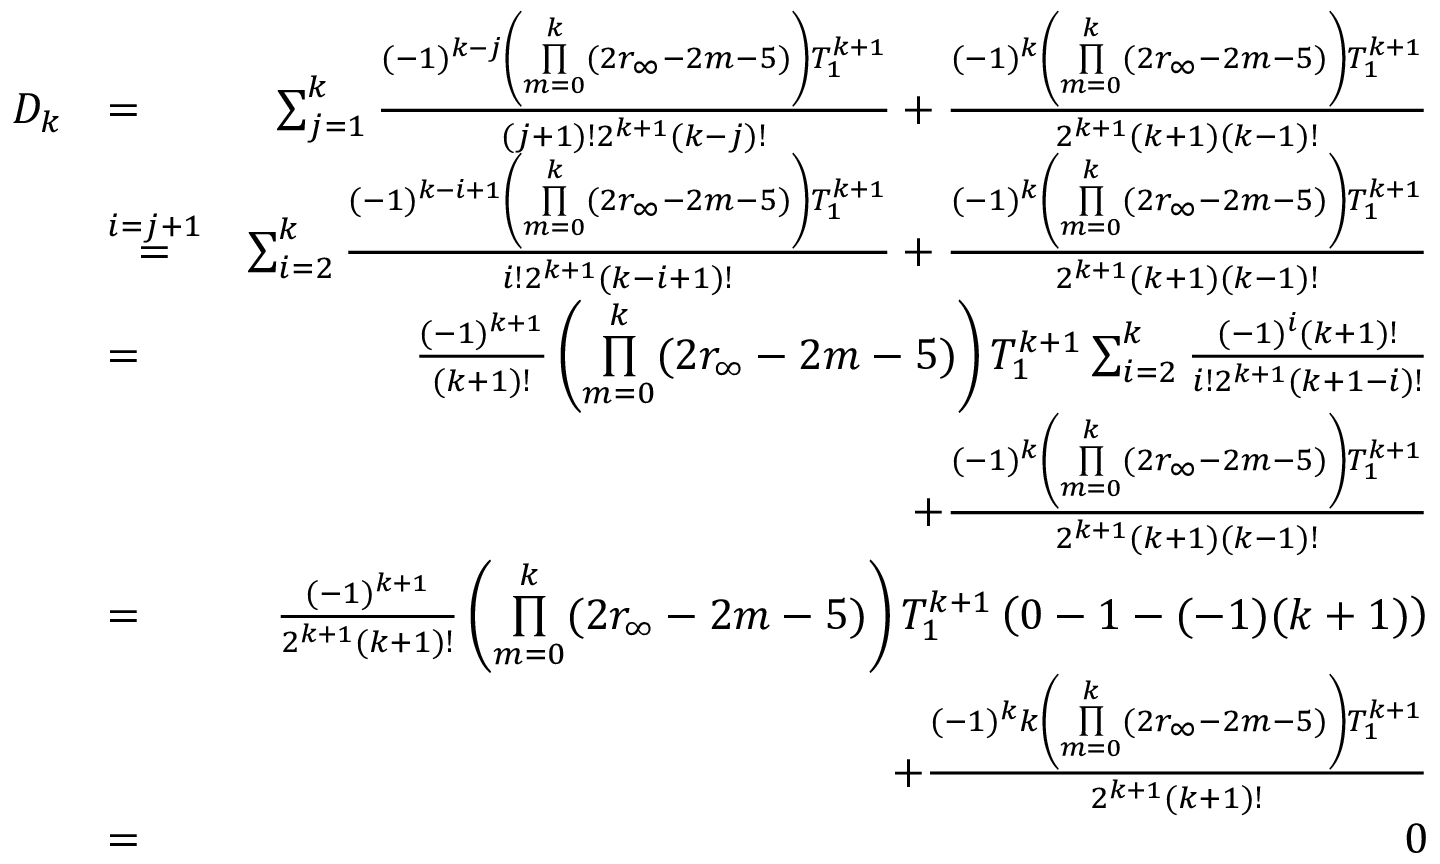Convert formula to latex. <formula><loc_0><loc_0><loc_500><loc_500>\begin{array} { r l r } { D _ { k } } & { = } & { \sum _ { j = 1 } ^ { k } \frac { ( - 1 ) ^ { k - j } \left ( \underset { m = 0 } { \overset { k } { \prod } } ( 2 r _ { \infty } - 2 m - 5 ) \right ) T _ { 1 } ^ { k + 1 } } { ( j + 1 ) ! 2 ^ { k + 1 } ( k - j ) ! } + \frac { ( - 1 ) ^ { k } \left ( \underset { m = 0 } { \overset { k } { \prod } } ( 2 r _ { \infty } - 2 m - 5 ) \right ) T _ { 1 } ^ { k + 1 } } { 2 ^ { k + 1 } ( k + 1 ) ( k - 1 ) ! } } \\ & { \overset { i = j + 1 } { = } } & { \sum _ { i = 2 } ^ { k } \frac { ( - 1 ) ^ { k - i + 1 } \left ( \underset { m = 0 } { \overset { k } { \prod } } ( 2 r _ { \infty } - 2 m - 5 ) \right ) T _ { 1 } ^ { k + 1 } } { i ! 2 ^ { k + 1 } ( k - i + 1 ) ! } + \frac { ( - 1 ) ^ { k } \left ( \underset { m = 0 } { \overset { k } { \prod } } ( 2 r _ { \infty } - 2 m - 5 ) \right ) T _ { 1 } ^ { k + 1 } } { 2 ^ { k + 1 } ( k + 1 ) ( k - 1 ) ! } } \\ & { = } & { \frac { ( - 1 ) ^ { k + 1 } } { ( k + 1 ) ! } \left ( \underset { m = 0 } { \overset { k } { \prod } } ( 2 r _ { \infty } - 2 m - 5 ) \right ) T _ { 1 } ^ { k + 1 } \sum _ { i = 2 } ^ { k } \frac { ( - 1 ) ^ { i } ( k + 1 ) ! } { i ! 2 ^ { k + 1 } ( k + 1 - i ) ! } } \\ & { + \frac { ( - 1 ) ^ { k } \left ( \underset { m = 0 } { \overset { k } { \prod } } ( 2 r _ { \infty } - 2 m - 5 ) \right ) T _ { 1 } ^ { k + 1 } } { 2 ^ { k + 1 } ( k + 1 ) ( k - 1 ) ! } } \\ & { = } & { \frac { ( - 1 ) ^ { k + 1 } } { 2 ^ { k + 1 } ( k + 1 ) ! } \left ( \underset { m = 0 } { \overset { k } { \prod } } ( 2 r _ { \infty } - 2 m - 5 ) \right ) T _ { 1 } ^ { k + 1 } \left ( 0 - 1 - ( - 1 ) ( k + 1 ) \right ) } \\ & { + \frac { ( - 1 ) ^ { k } k \left ( \underset { m = 0 } { \overset { k } { \prod } } ( 2 r _ { \infty } - 2 m - 5 ) \right ) T _ { 1 } ^ { k + 1 } } { 2 ^ { k + 1 } ( k + 1 ) ! } } \\ & { = } & { 0 } \end{array}</formula> 